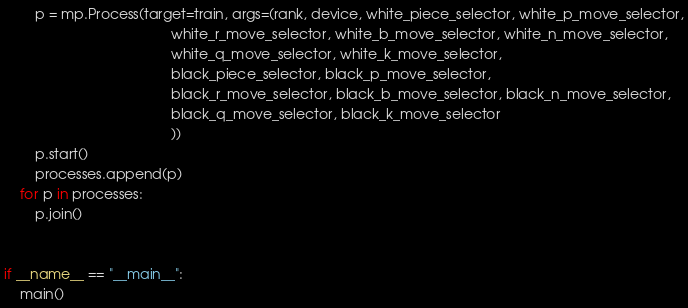Convert code to text. <code><loc_0><loc_0><loc_500><loc_500><_Python_>        p = mp.Process(target=train, args=(rank, device, white_piece_selector, white_p_move_selector,
                                           white_r_move_selector, white_b_move_selector, white_n_move_selector,
                                           white_q_move_selector, white_k_move_selector,
                                           black_piece_selector, black_p_move_selector,
                                           black_r_move_selector, black_b_move_selector, black_n_move_selector,
                                           black_q_move_selector, black_k_move_selector
                                           ))
        p.start()
        processes.append(p)
    for p in processes:
        p.join()


if __name__ == "__main__":
    main()
</code> 